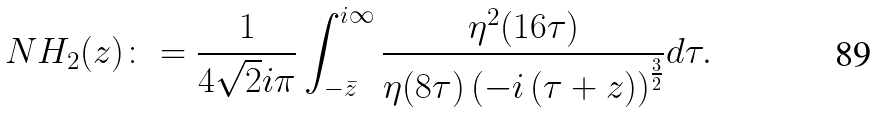<formula> <loc_0><loc_0><loc_500><loc_500>N H _ { 2 } ( z ) \colon = \frac { 1 } { 4 \sqrt { 2 } i \pi } \int _ { - \bar { z } } ^ { i \infty } \frac { \eta ^ { 2 } ( 1 6 \tau ) } { \eta ( 8 \tau ) \left ( - i \left ( \tau + z \right ) \right ) ^ { \frac { 3 } { 2 } } } d \tau .</formula> 